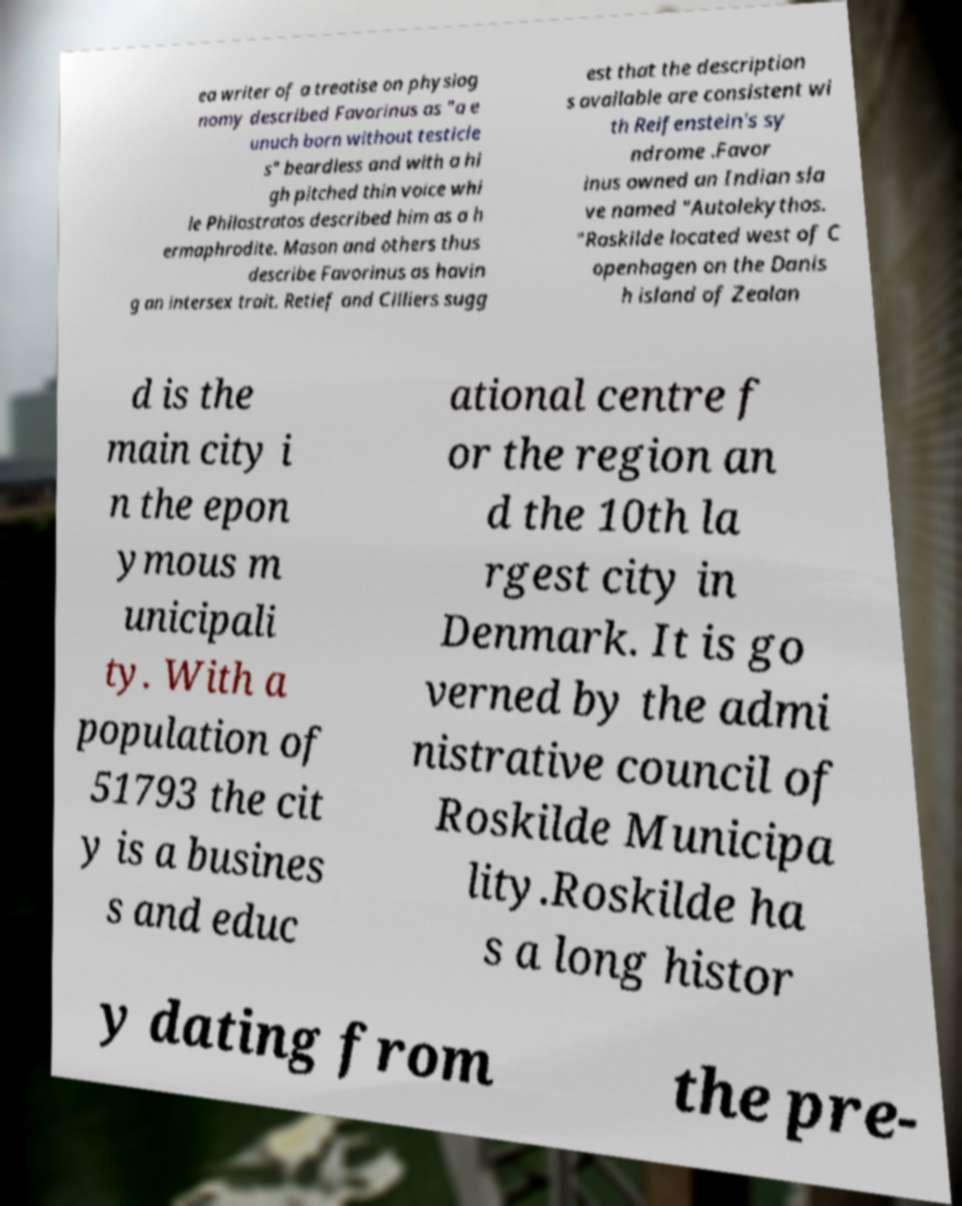Could you assist in decoding the text presented in this image and type it out clearly? ea writer of a treatise on physiog nomy described Favorinus as "a e unuch born without testicle s" beardless and with a hi gh pitched thin voice whi le Philostratos described him as a h ermaphrodite. Mason and others thus describe Favorinus as havin g an intersex trait. Retief and Cilliers sugg est that the description s available are consistent wi th Reifenstein's sy ndrome .Favor inus owned an Indian sla ve named "Autolekythos. "Roskilde located west of C openhagen on the Danis h island of Zealan d is the main city i n the epon ymous m unicipali ty. With a population of 51793 the cit y is a busines s and educ ational centre f or the region an d the 10th la rgest city in Denmark. It is go verned by the admi nistrative council of Roskilde Municipa lity.Roskilde ha s a long histor y dating from the pre- 